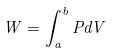Convert formula to latex. <formula><loc_0><loc_0><loc_500><loc_500>W = \int _ { a } ^ { b } P d V</formula> 